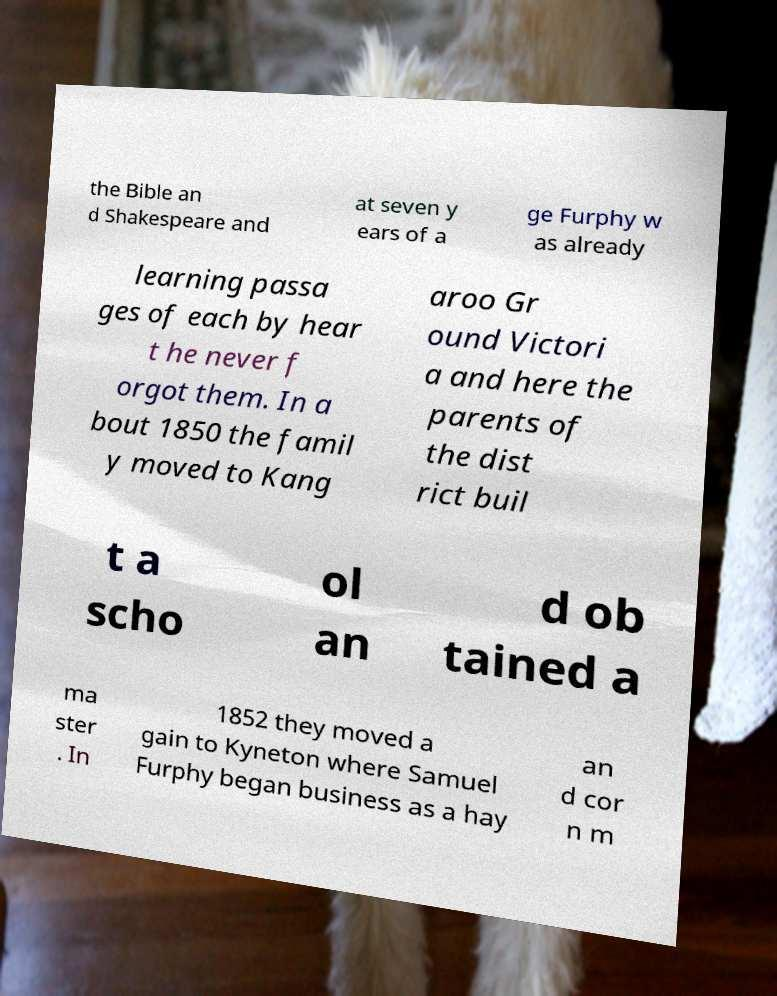Could you assist in decoding the text presented in this image and type it out clearly? the Bible an d Shakespeare and at seven y ears of a ge Furphy w as already learning passa ges of each by hear t he never f orgot them. In a bout 1850 the famil y moved to Kang aroo Gr ound Victori a and here the parents of the dist rict buil t a scho ol an d ob tained a ma ster . In 1852 they moved a gain to Kyneton where Samuel Furphy began business as a hay an d cor n m 